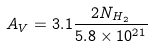<formula> <loc_0><loc_0><loc_500><loc_500>A _ { V } = 3 . 1 \frac { 2 N _ { H _ { 2 } } } { 5 . 8 \times 1 0 ^ { 2 1 } }</formula> 